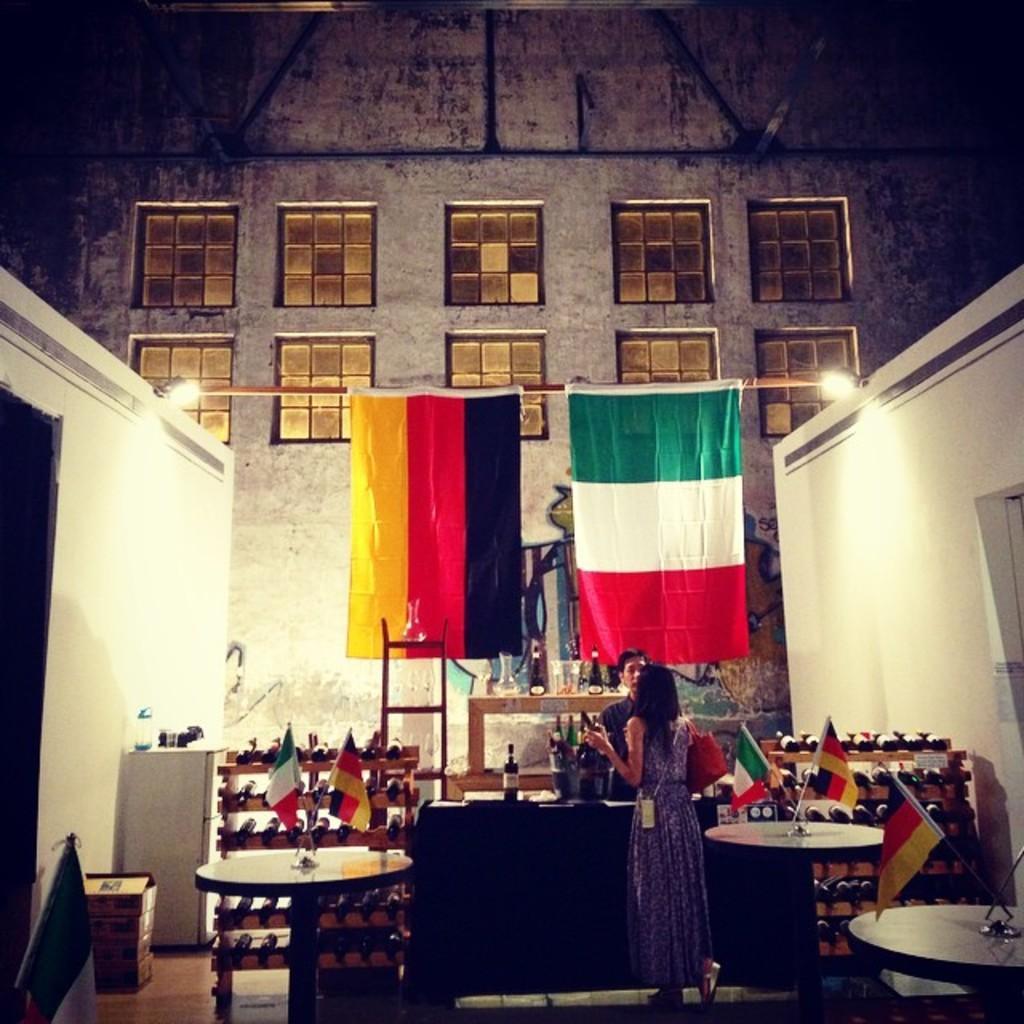Can you describe this image briefly? A woman wearing a gown is holding a bag. There are a many tables. There are two flags each. In the background there is a wall with windows. There are two flags hanging. Also there are two lights in the wall. There are many cupboards. On the cupboards there are many bottles. And a person is standing in front of the lady. There are some boxes and cupboard on the left corner. 